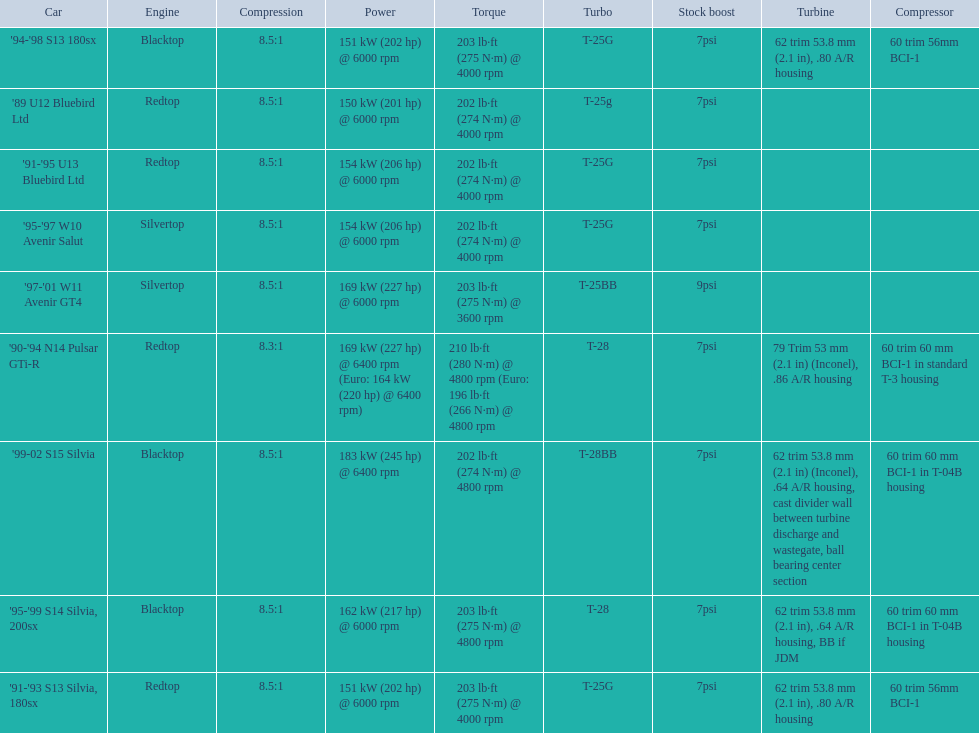What are the listed hp of the cars? 150 kW (201 hp) @ 6000 rpm, 154 kW (206 hp) @ 6000 rpm, 154 kW (206 hp) @ 6000 rpm, 169 kW (227 hp) @ 6000 rpm, 169 kW (227 hp) @ 6400 rpm (Euro: 164 kW (220 hp) @ 6400 rpm), 151 kW (202 hp) @ 6000 rpm, 151 kW (202 hp) @ 6000 rpm, 162 kW (217 hp) @ 6000 rpm, 183 kW (245 hp) @ 6400 rpm. Which is the only car with over 230 hp? '99-02 S15 Silvia. 